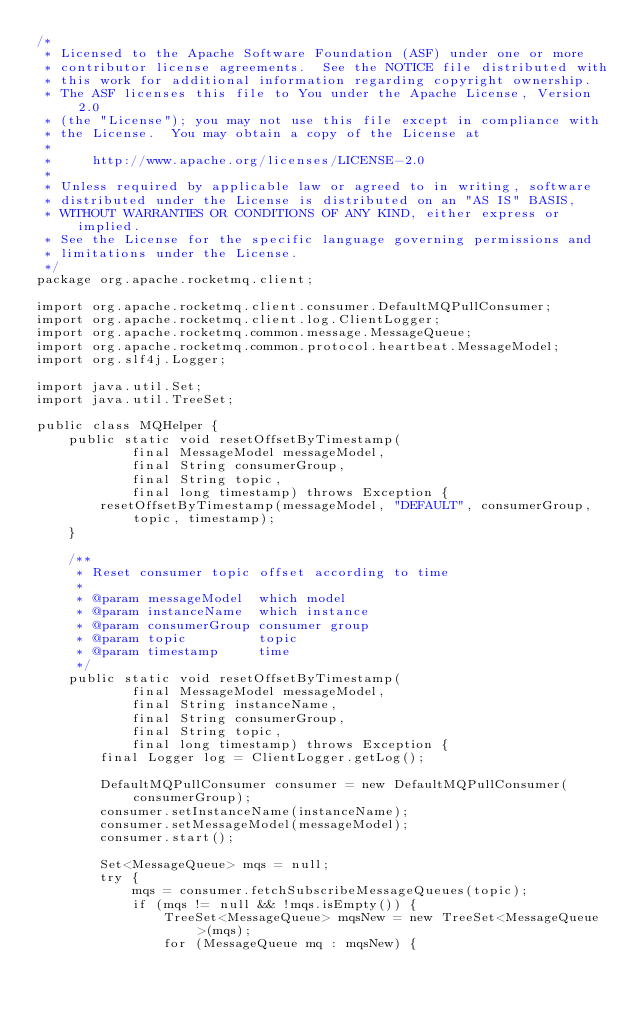Convert code to text. <code><loc_0><loc_0><loc_500><loc_500><_Java_>/*
 * Licensed to the Apache Software Foundation (ASF) under one or more
 * contributor license agreements.  See the NOTICE file distributed with
 * this work for additional information regarding copyright ownership.
 * The ASF licenses this file to You under the Apache License, Version 2.0
 * (the "License"); you may not use this file except in compliance with
 * the License.  You may obtain a copy of the License at
 *
 *     http://www.apache.org/licenses/LICENSE-2.0
 *
 * Unless required by applicable law or agreed to in writing, software
 * distributed under the License is distributed on an "AS IS" BASIS,
 * WITHOUT WARRANTIES OR CONDITIONS OF ANY KIND, either express or implied.
 * See the License for the specific language governing permissions and
 * limitations under the License.
 */
package org.apache.rocketmq.client;

import org.apache.rocketmq.client.consumer.DefaultMQPullConsumer;
import org.apache.rocketmq.client.log.ClientLogger;
import org.apache.rocketmq.common.message.MessageQueue;
import org.apache.rocketmq.common.protocol.heartbeat.MessageModel;
import org.slf4j.Logger;

import java.util.Set;
import java.util.TreeSet;

public class MQHelper {
    public static void resetOffsetByTimestamp(
            final MessageModel messageModel,
            final String consumerGroup,
            final String topic,
            final long timestamp) throws Exception {
        resetOffsetByTimestamp(messageModel, "DEFAULT", consumerGroup, topic, timestamp);
    }

    /**
     * Reset consumer topic offset according to time
     *
     * @param messageModel  which model
     * @param instanceName  which instance
     * @param consumerGroup consumer group
     * @param topic         topic
     * @param timestamp     time
     */
    public static void resetOffsetByTimestamp(
            final MessageModel messageModel,
            final String instanceName,
            final String consumerGroup,
            final String topic,
            final long timestamp) throws Exception {
        final Logger log = ClientLogger.getLog();

        DefaultMQPullConsumer consumer = new DefaultMQPullConsumer(consumerGroup);
        consumer.setInstanceName(instanceName);
        consumer.setMessageModel(messageModel);
        consumer.start();

        Set<MessageQueue> mqs = null;
        try {
            mqs = consumer.fetchSubscribeMessageQueues(topic);
            if (mqs != null && !mqs.isEmpty()) {
                TreeSet<MessageQueue> mqsNew = new TreeSet<MessageQueue>(mqs);
                for (MessageQueue mq : mqsNew) {</code> 